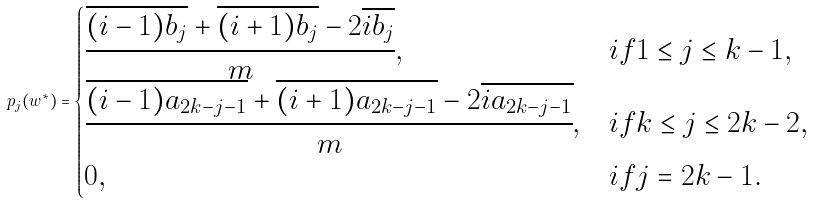Convert formula to latex. <formula><loc_0><loc_0><loc_500><loc_500>p _ { j } ( w ^ { * } ) = \begin{cases} \cfrac { \overline { ( i - 1 ) b _ { j } } + \overline { ( i + 1 ) b _ { j } } - 2 \overline { i b _ { j } } } { m } , \, & i f 1 \leq j \leq k - 1 , \\ \cfrac { \overline { ( i - 1 ) a _ { 2 k - j - 1 } } + \overline { ( i + 1 ) a _ { 2 k - j - 1 } } - 2 \overline { i a _ { 2 k - j - 1 } } } { m } , & i f k \leq j \leq 2 k - 2 , \\ 0 , & i f j = 2 k - 1 . \end{cases}</formula> 